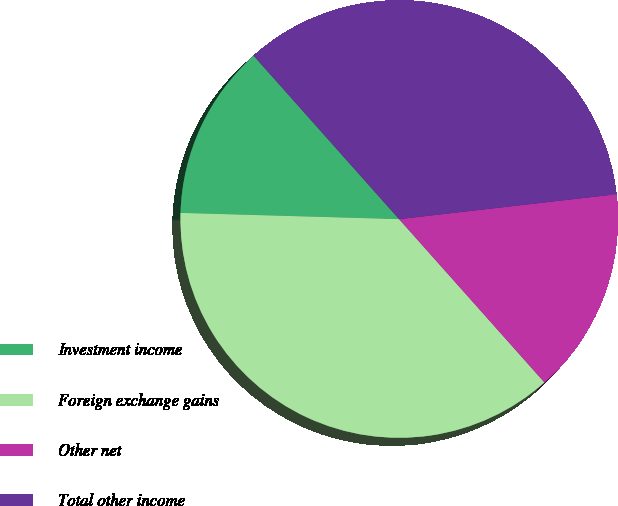Convert chart. <chart><loc_0><loc_0><loc_500><loc_500><pie_chart><fcel>Investment income<fcel>Foreign exchange gains<fcel>Other net<fcel>Total other income<nl><fcel>12.97%<fcel>37.03%<fcel>15.24%<fcel>34.76%<nl></chart> 